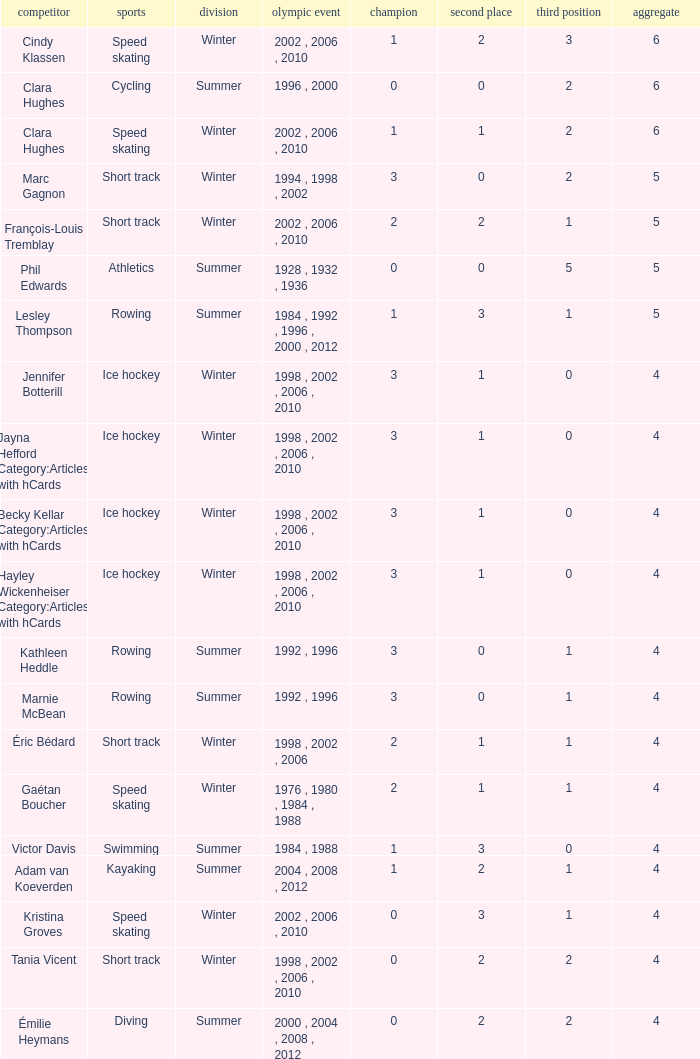What is the highest total medals winter athlete Clara Hughes has? 6.0. 